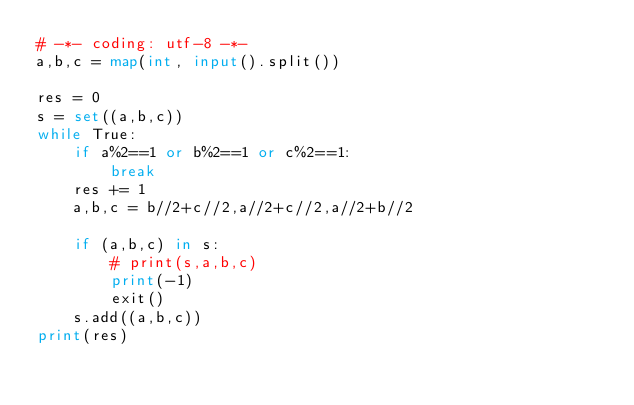<code> <loc_0><loc_0><loc_500><loc_500><_Python_># -*- coding: utf-8 -*-
a,b,c = map(int, input().split())

res = 0
s = set((a,b,c))
while True:
    if a%2==1 or b%2==1 or c%2==1:
        break
    res += 1
    a,b,c = b//2+c//2,a//2+c//2,a//2+b//2

    if (a,b,c) in s:
        # print(s,a,b,c)
        print(-1)
        exit()
    s.add((a,b,c))
print(res)
</code> 